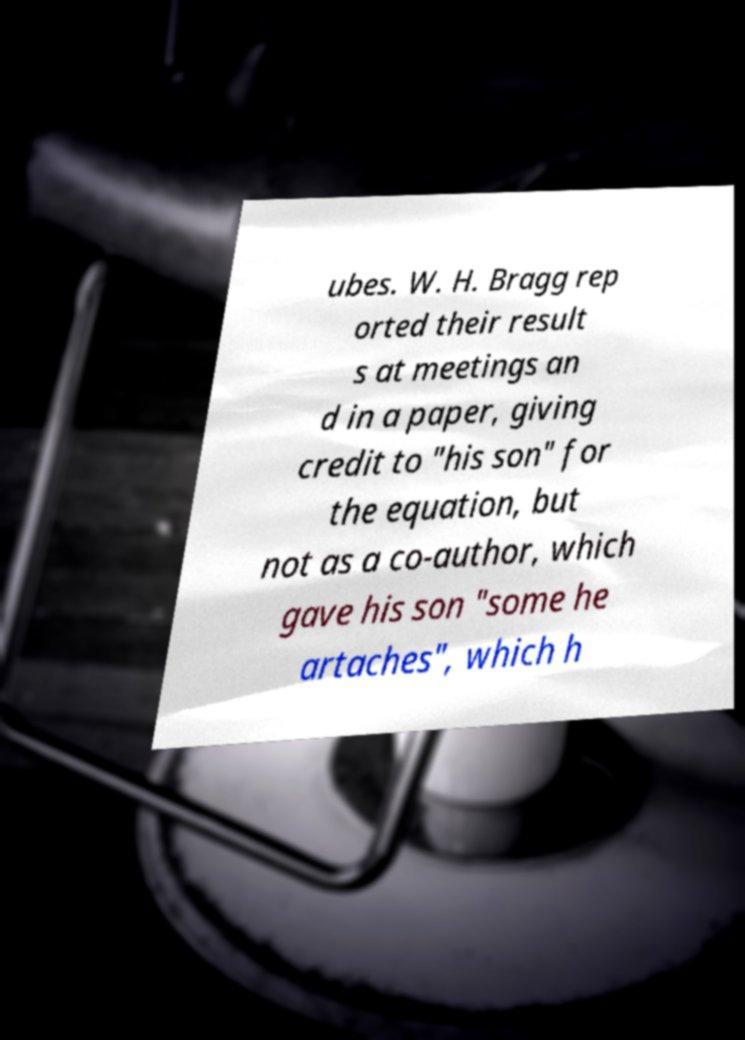Please identify and transcribe the text found in this image. ubes. W. H. Bragg rep orted their result s at meetings an d in a paper, giving credit to "his son" for the equation, but not as a co-author, which gave his son "some he artaches", which h 